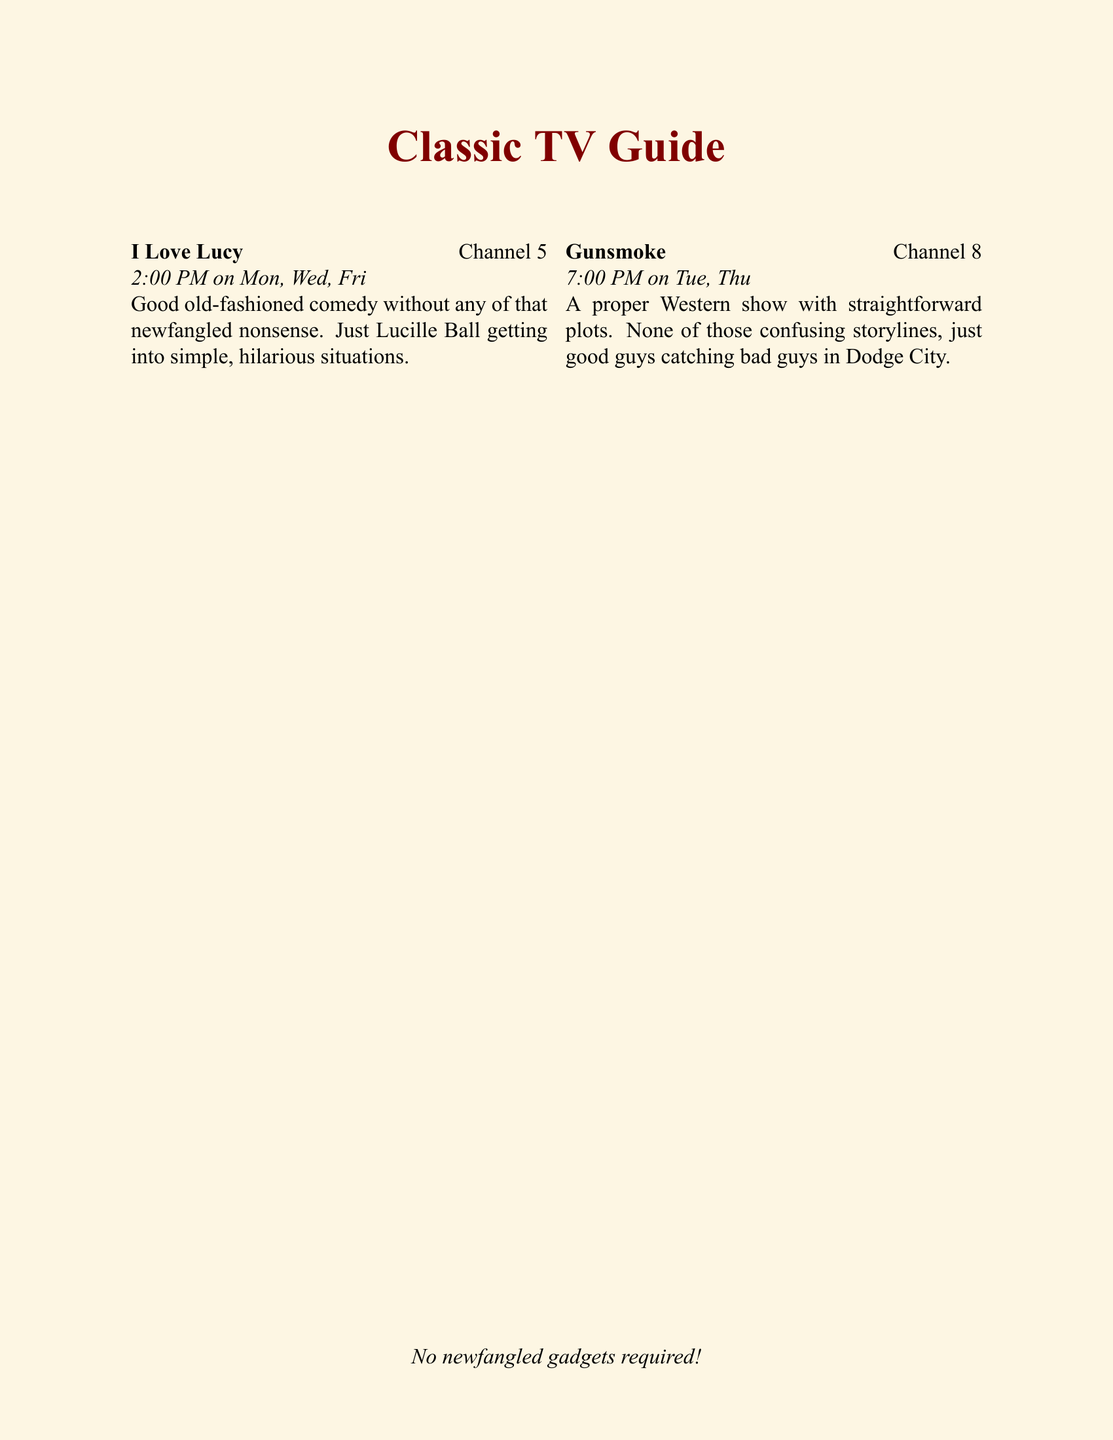What time does "I Love Lucy" air? "I Love Lucy" airs at 2:00 PM on Monday, Wednesday, and Friday.
Answer: 2:00 PM On which channel does "Gunsmoke" come on? "Gunsmoke" is shown on Channel 8 at 7:00 PM on Tuesday and Thursday.
Answer: Channel 8 Which classic show is scheduled for 9:00 PM on Sunday? The show scheduled for 9:00 PM on Sunday is "Columbo."
Answer: Columbo How many days a week does "The Andy Griffith Show" air? "The Andy Griffith Show" airs five days a week: Monday, Tuesday, Wednesday, Thursday, and Friday.
Answer: Five days What type of show is "M*A*S*H"? "M*A*S*H" is described as a show about army doctors mixing humor with serious moments.
Answer: Army doctors show What is the air time for "Bonanza"? "Bonanza" airs at 8:00 PM on Saturday.
Answer: 8:00 PM How often does the schedule change? The schedule is subject to change, but not too often.
Answer: Not too often Which show has a straightforward family theme? "The Brady Bunch" is a straightforward family show.
Answer: The Brady Bunch What is a special note about the airing times? All times are in Eastern Standard Time.
Answer: Eastern Standard Time 